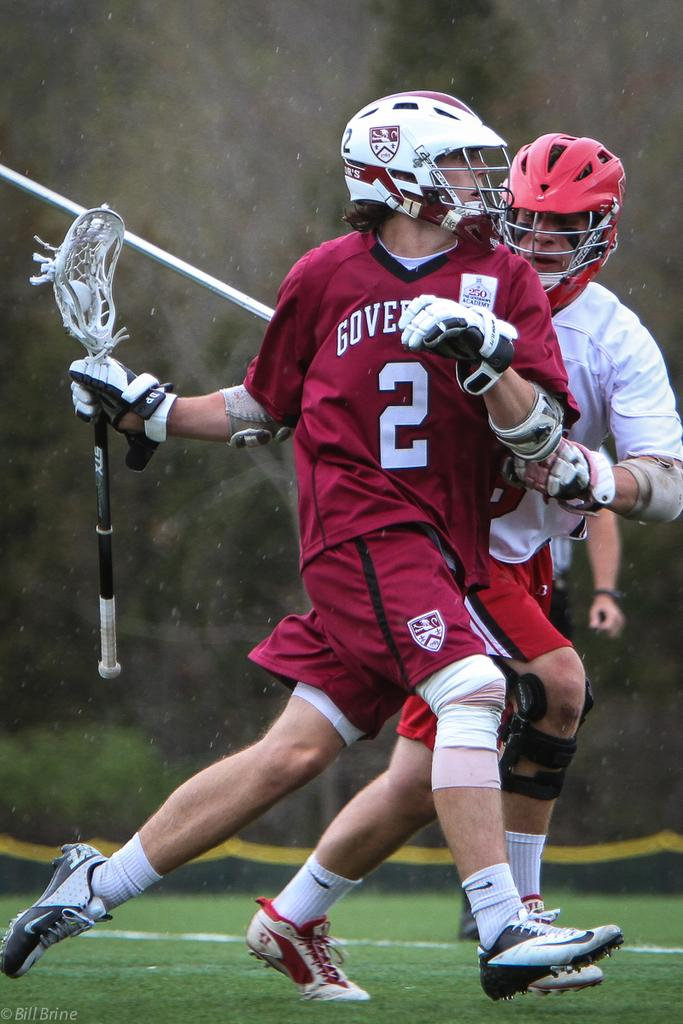<image>
Relay a brief, clear account of the picture shown. The lacrosse player has the number 2 on his jersey. 